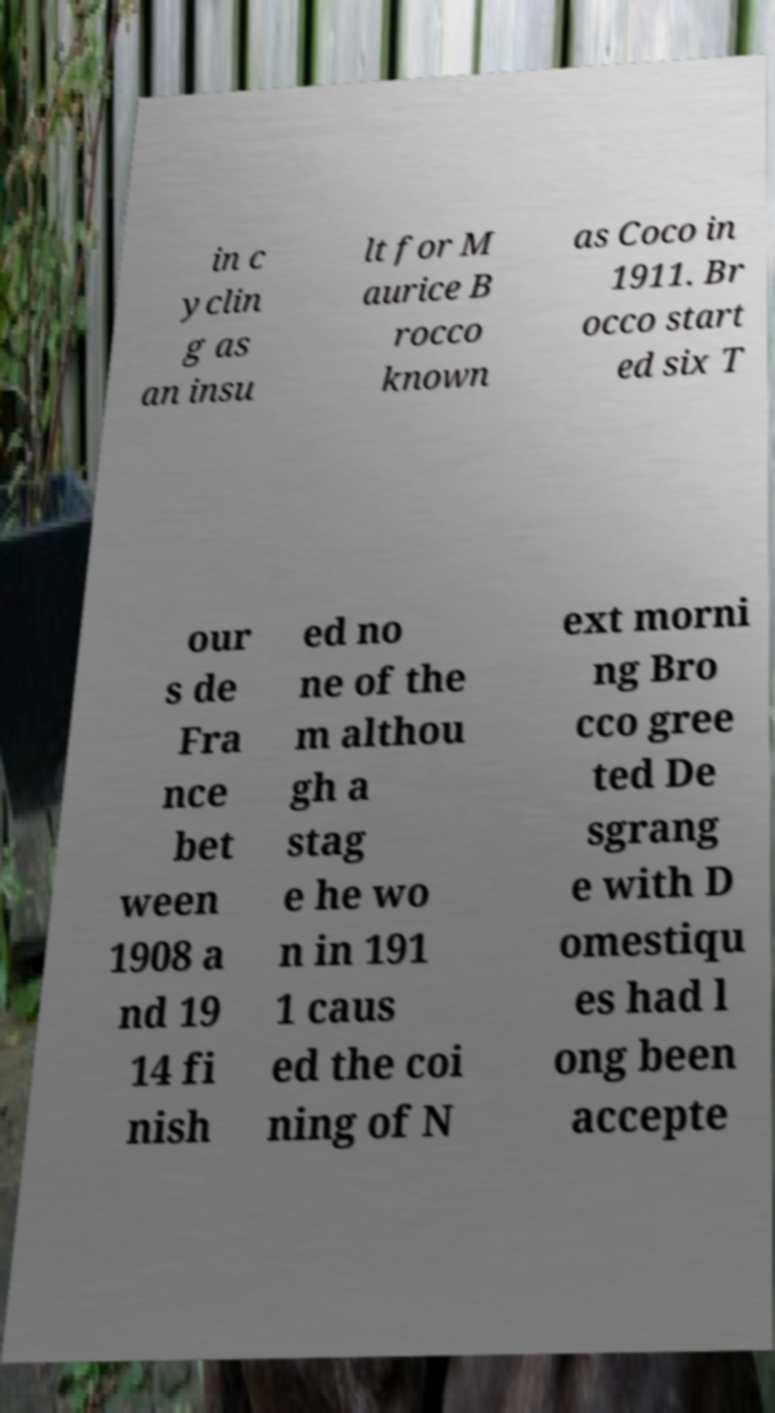What messages or text are displayed in this image? I need them in a readable, typed format. in c yclin g as an insu lt for M aurice B rocco known as Coco in 1911. Br occo start ed six T our s de Fra nce bet ween 1908 a nd 19 14 fi nish ed no ne of the m althou gh a stag e he wo n in 191 1 caus ed the coi ning of N ext morni ng Bro cco gree ted De sgrang e with D omestiqu es had l ong been accepte 